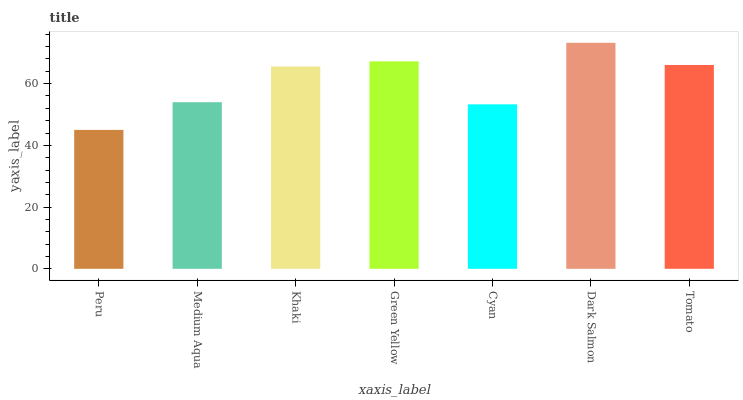Is Peru the minimum?
Answer yes or no. Yes. Is Dark Salmon the maximum?
Answer yes or no. Yes. Is Medium Aqua the minimum?
Answer yes or no. No. Is Medium Aqua the maximum?
Answer yes or no. No. Is Medium Aqua greater than Peru?
Answer yes or no. Yes. Is Peru less than Medium Aqua?
Answer yes or no. Yes. Is Peru greater than Medium Aqua?
Answer yes or no. No. Is Medium Aqua less than Peru?
Answer yes or no. No. Is Khaki the high median?
Answer yes or no. Yes. Is Khaki the low median?
Answer yes or no. Yes. Is Dark Salmon the high median?
Answer yes or no. No. Is Peru the low median?
Answer yes or no. No. 